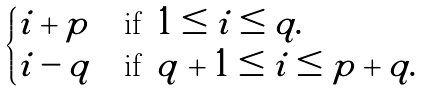<formula> <loc_0><loc_0><loc_500><loc_500>\begin{cases} i + p & \text {if } \, 1 \leq i \leq q . \\ i - q & \text {if } \, q + 1 \leq i \leq p + q . \end{cases}</formula> 